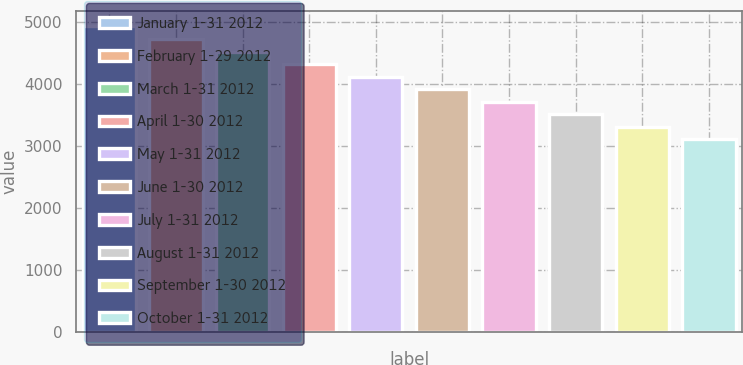Convert chart. <chart><loc_0><loc_0><loc_500><loc_500><bar_chart><fcel>January 1-31 2012<fcel>February 1-29 2012<fcel>March 1-31 2012<fcel>April 1-30 2012<fcel>May 1-31 2012<fcel>June 1-30 2012<fcel>July 1-31 2012<fcel>August 1-31 2012<fcel>September 1-30 2012<fcel>October 1-31 2012<nl><fcel>4920.2<fcel>4718.4<fcel>4516.6<fcel>4314.8<fcel>4113<fcel>3911.2<fcel>3709.4<fcel>3507.6<fcel>3305.8<fcel>3104<nl></chart> 